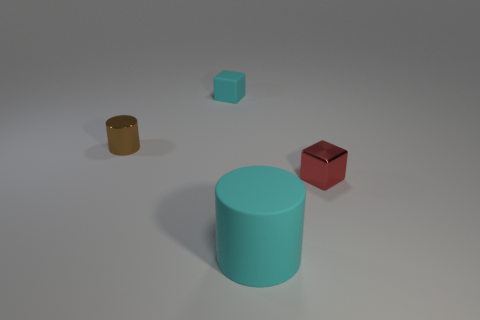What is the color of the metallic thing that is the same size as the shiny cylinder?
Offer a very short reply. Red. Is the number of tiny cylinders that are left of the tiny cylinder greater than the number of brown metallic cylinders?
Your response must be concise. No. The object that is both in front of the brown metal thing and behind the large cylinder is made of what material?
Ensure brevity in your answer.  Metal. Do the matte object to the left of the large cyan object and the metal object that is right of the metal cylinder have the same color?
Provide a short and direct response. No. How many other things are there of the same size as the metallic cube?
Give a very brief answer. 2. Are there an equal number of big purple shiny objects and small matte cubes?
Provide a short and direct response. No. Are there any cyan things that are to the right of the big cyan thing to the left of the small metal object that is in front of the brown object?
Offer a very short reply. No. Is the object that is to the left of the matte block made of the same material as the big object?
Make the answer very short. No. The other thing that is the same shape as the large object is what color?
Make the answer very short. Brown. Is there any other thing that is the same shape as the big object?
Give a very brief answer. Yes. 